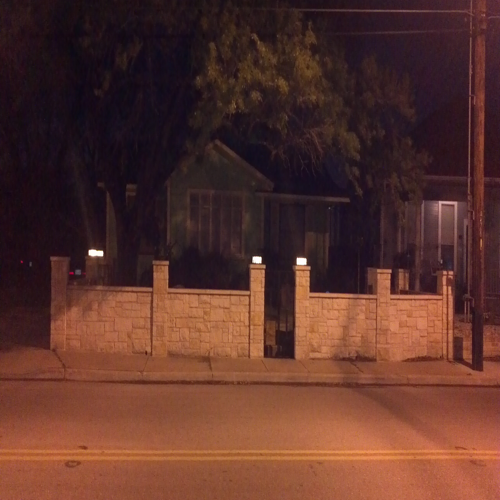Is there any motion blur in the photo? After examining the image closely, I can confirm there is no motion blur observable in the photo. The lighting and edges suggest a clear, stable image capture. 